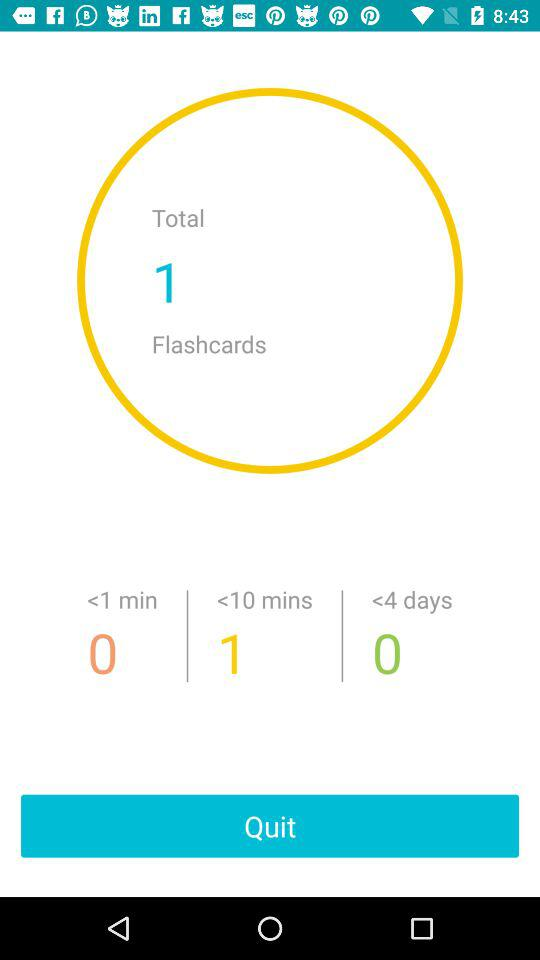How many flashcards in total are there on the screen? There is 1 flashcard in total on the screen. 